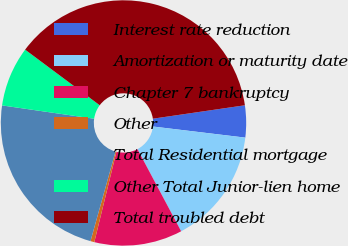<chart> <loc_0><loc_0><loc_500><loc_500><pie_chart><fcel>Interest rate reduction<fcel>Amortization or maturity date<fcel>Chapter 7 bankruptcy<fcel>Other<fcel>Total Residential mortgage<fcel>Other Total Junior-lien home<fcel>Total troubled debt<nl><fcel>4.21%<fcel>15.31%<fcel>11.61%<fcel>0.51%<fcel>22.95%<fcel>7.91%<fcel>37.5%<nl></chart> 